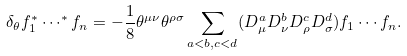Convert formula to latex. <formula><loc_0><loc_0><loc_500><loc_500>\delta _ { \theta } f _ { 1 } ^ { * } \cdots ^ { * } f _ { n } = - \frac { 1 } { 8 } \theta ^ { \mu \nu } \theta ^ { \rho \sigma } \sum _ { a < b , c < d } ( D _ { \mu } ^ { a } D _ { \nu } ^ { b } D _ { \rho } ^ { c } D _ { \sigma } ^ { d } ) f _ { 1 } \cdots f _ { n } .</formula> 